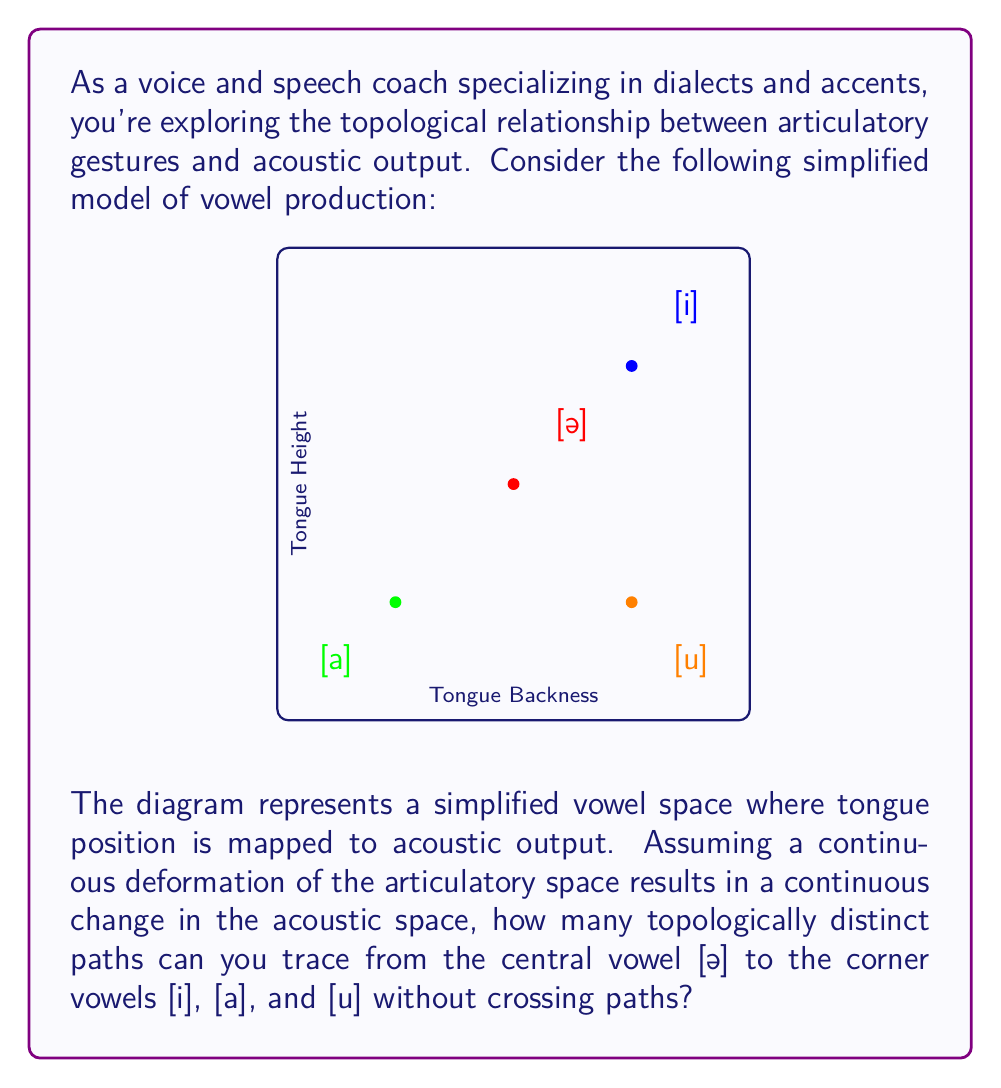Could you help me with this problem? To solve this problem, we need to apply concepts from topology to the given vowel space:

1) First, we recognize that the vowel space is topologically equivalent to a 2-dimensional plane, where each point represents a unique combination of tongue height and backness.

2) The central vowel [ə] and the three corner vowels [i], [a], and [u] can be considered as four distinct points in this plane.

3) We need to find topologically distinct paths from [ə] to each of the three corner vowels. Two paths are topologically distinct if one cannot be continuously deformed into the other without passing through one of the other vowel points.

4) In a 2D plane with four points, we can always draw three non-intersecting paths from one point to the other three. This is because:

   a) We can draw a straight line from [ə] to any corner vowel.
   b) For the second path, we can curve around the first path without intersecting it.
   c) For the third path, we can curve around both previous paths.

5) Mathematically, this can be represented as:

   $$\text{Number of distinct paths} = n - 1$$

   Where $n$ is the number of target points (in this case, 3 corner vowels).

6) Therefore, the number of topologically distinct paths is:

   $$3 - 1 = 2$$

This result indicates that there are 2 topologically distinct ways to arrange paths from [ə] to [i], [a], and [u] without crossing.
Answer: 2 